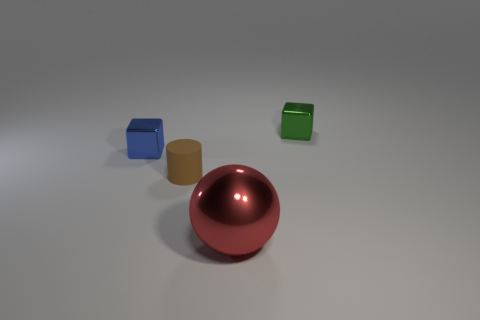What might be the significance of the different shapes and colors? The various shapes and colors could represent diversity and the uniqueness of items in a collection, indicating that each has its role or characteristic, much like individuals in a society. Do the lighting and shadows tell us anything about the composition? The lighting casts soft shadows, suggesting a diffuse light source which creates a calm and balanced atmosphere, highlighting the objects without harsh contrasts. 